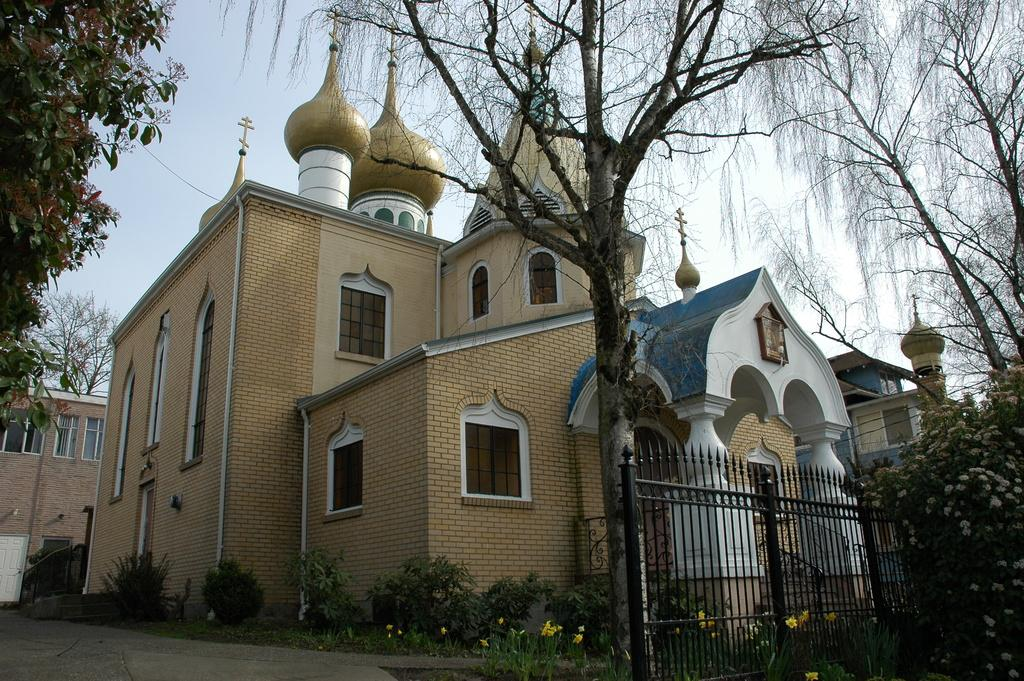What type of structures can be seen in the image? There are buildings in the image. What natural elements are present in the image? There are trees and plants in the image. What type of barrier is visible in the image? There is a metal fence in the image. What is the weather like in the image? The sky is cloudy in the image. What type of flora can be seen in the image? There are flowers visible in the image. What type of jelly is being used to sort the jeans in the image? There is no jelly or jeans present in the image; it features buildings, trees, plants, a metal fence, a cloudy sky, and flowers. 